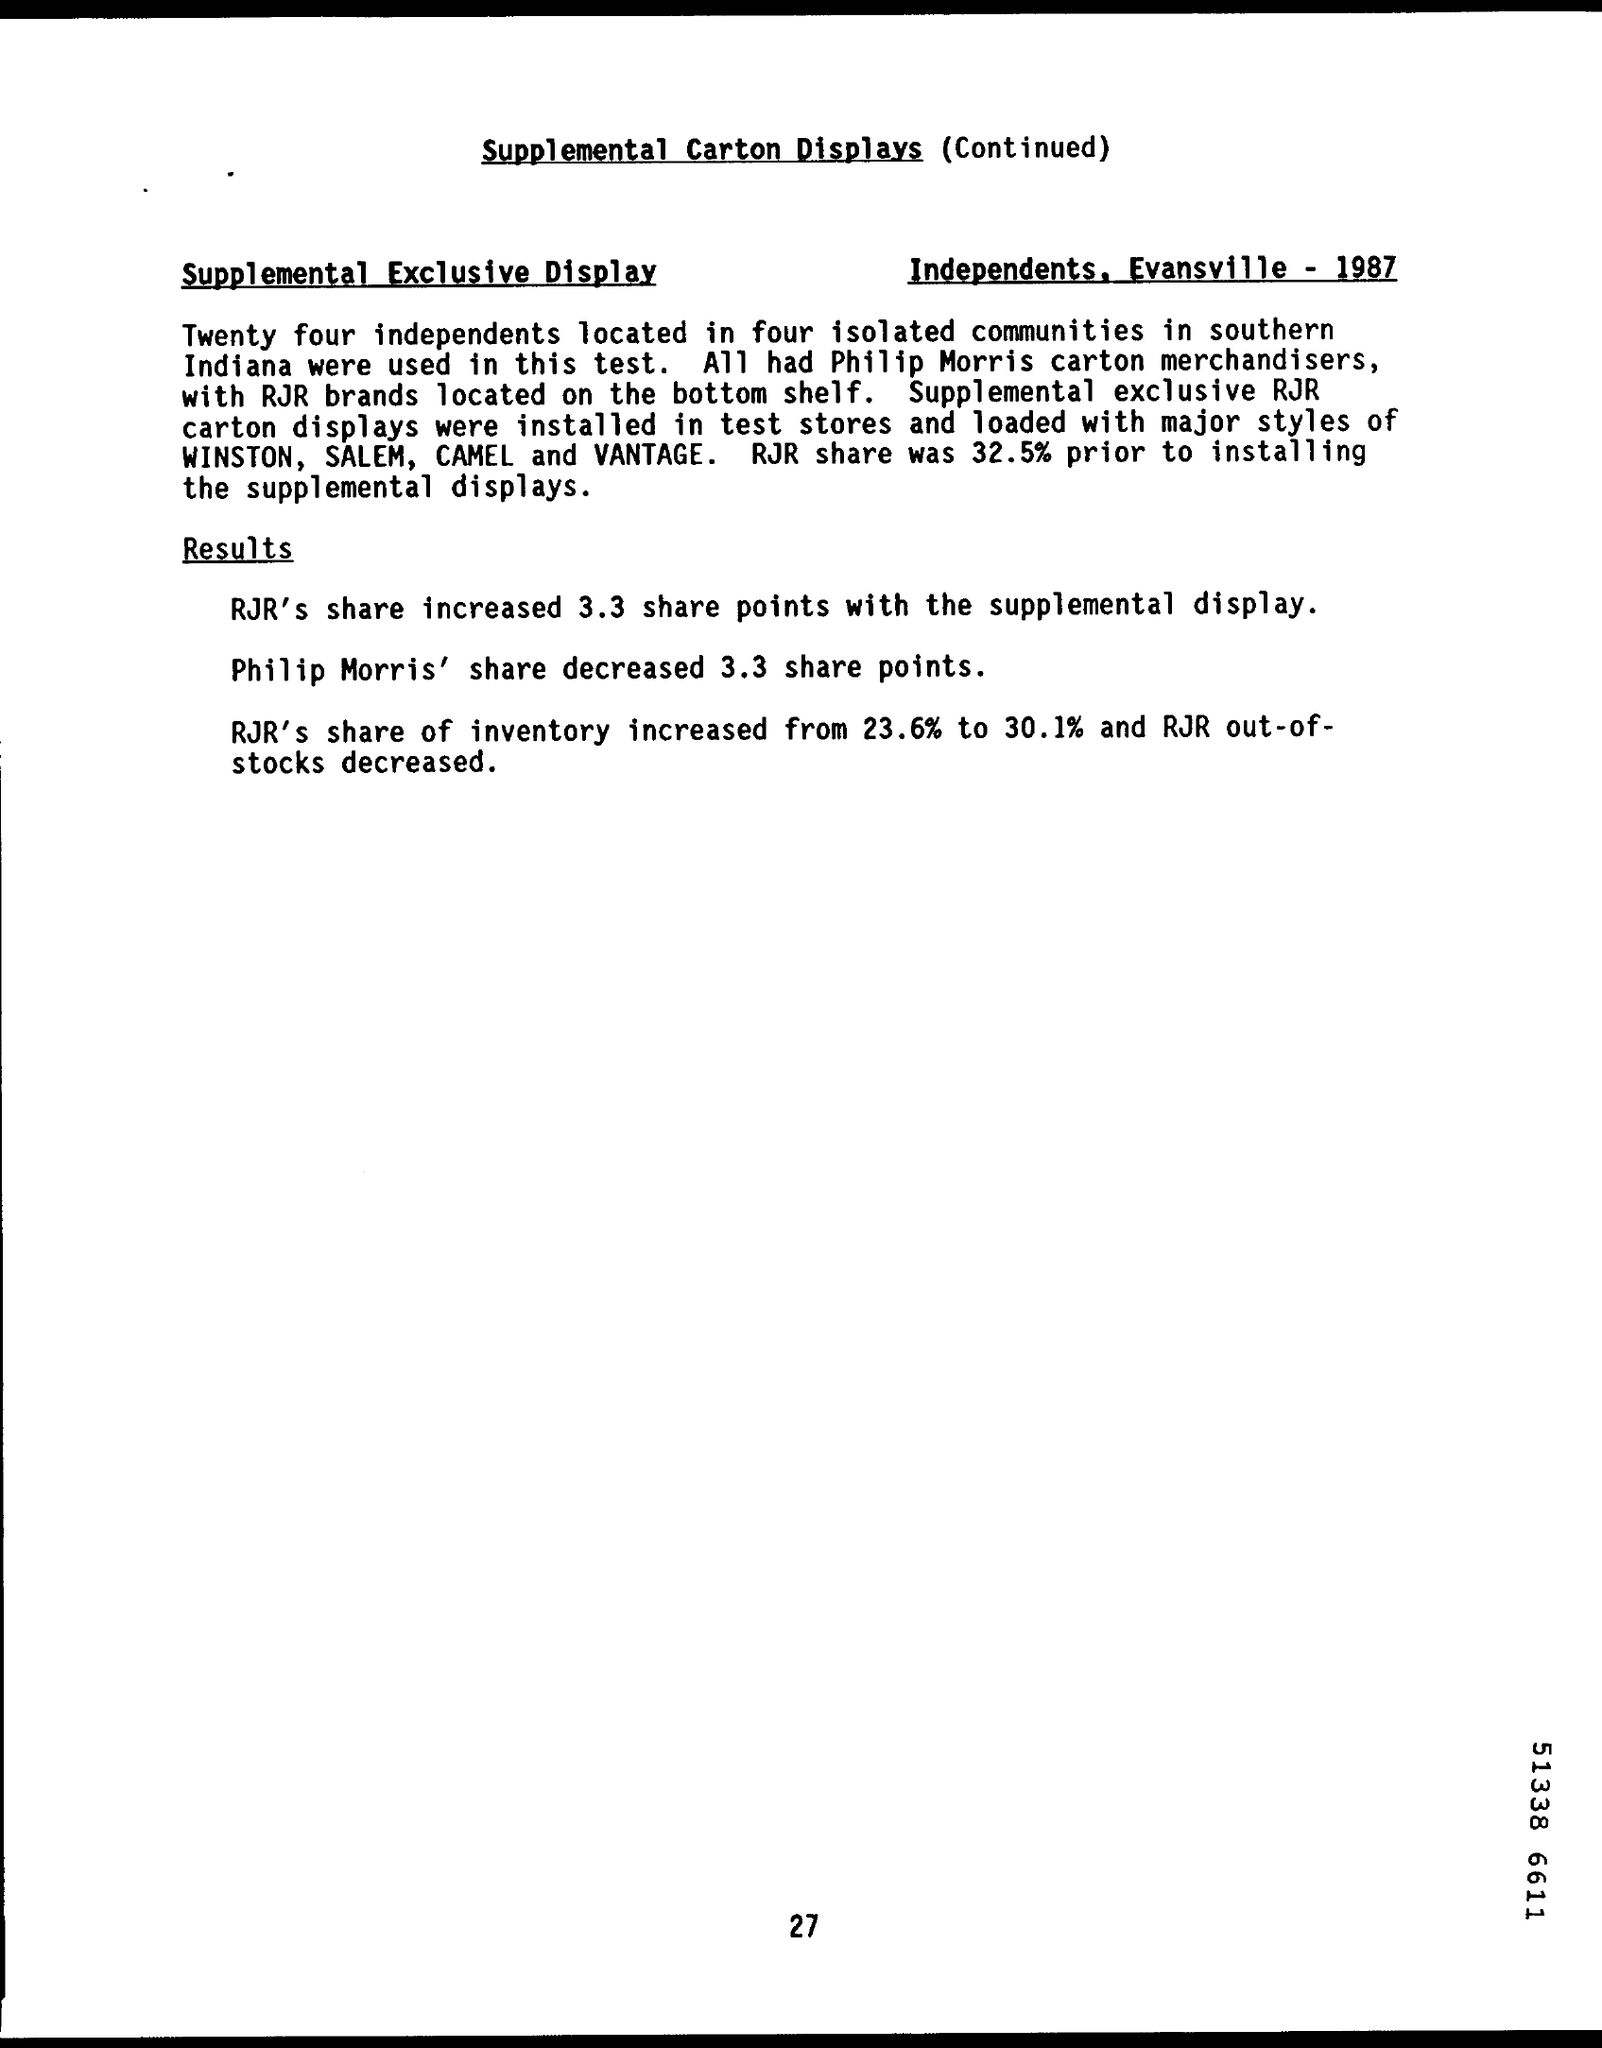How many independents were used in this test?
Provide a succinct answer. Twenty four. What was the RJR share prior to installing the supplemental displays?
Offer a terse response. 32.5%. By how much did rjr's share increase with the supplemental display?
Your response must be concise. 3.3. By how much did Philip Morris' share decrease?
Make the answer very short. 3.3 share points. 